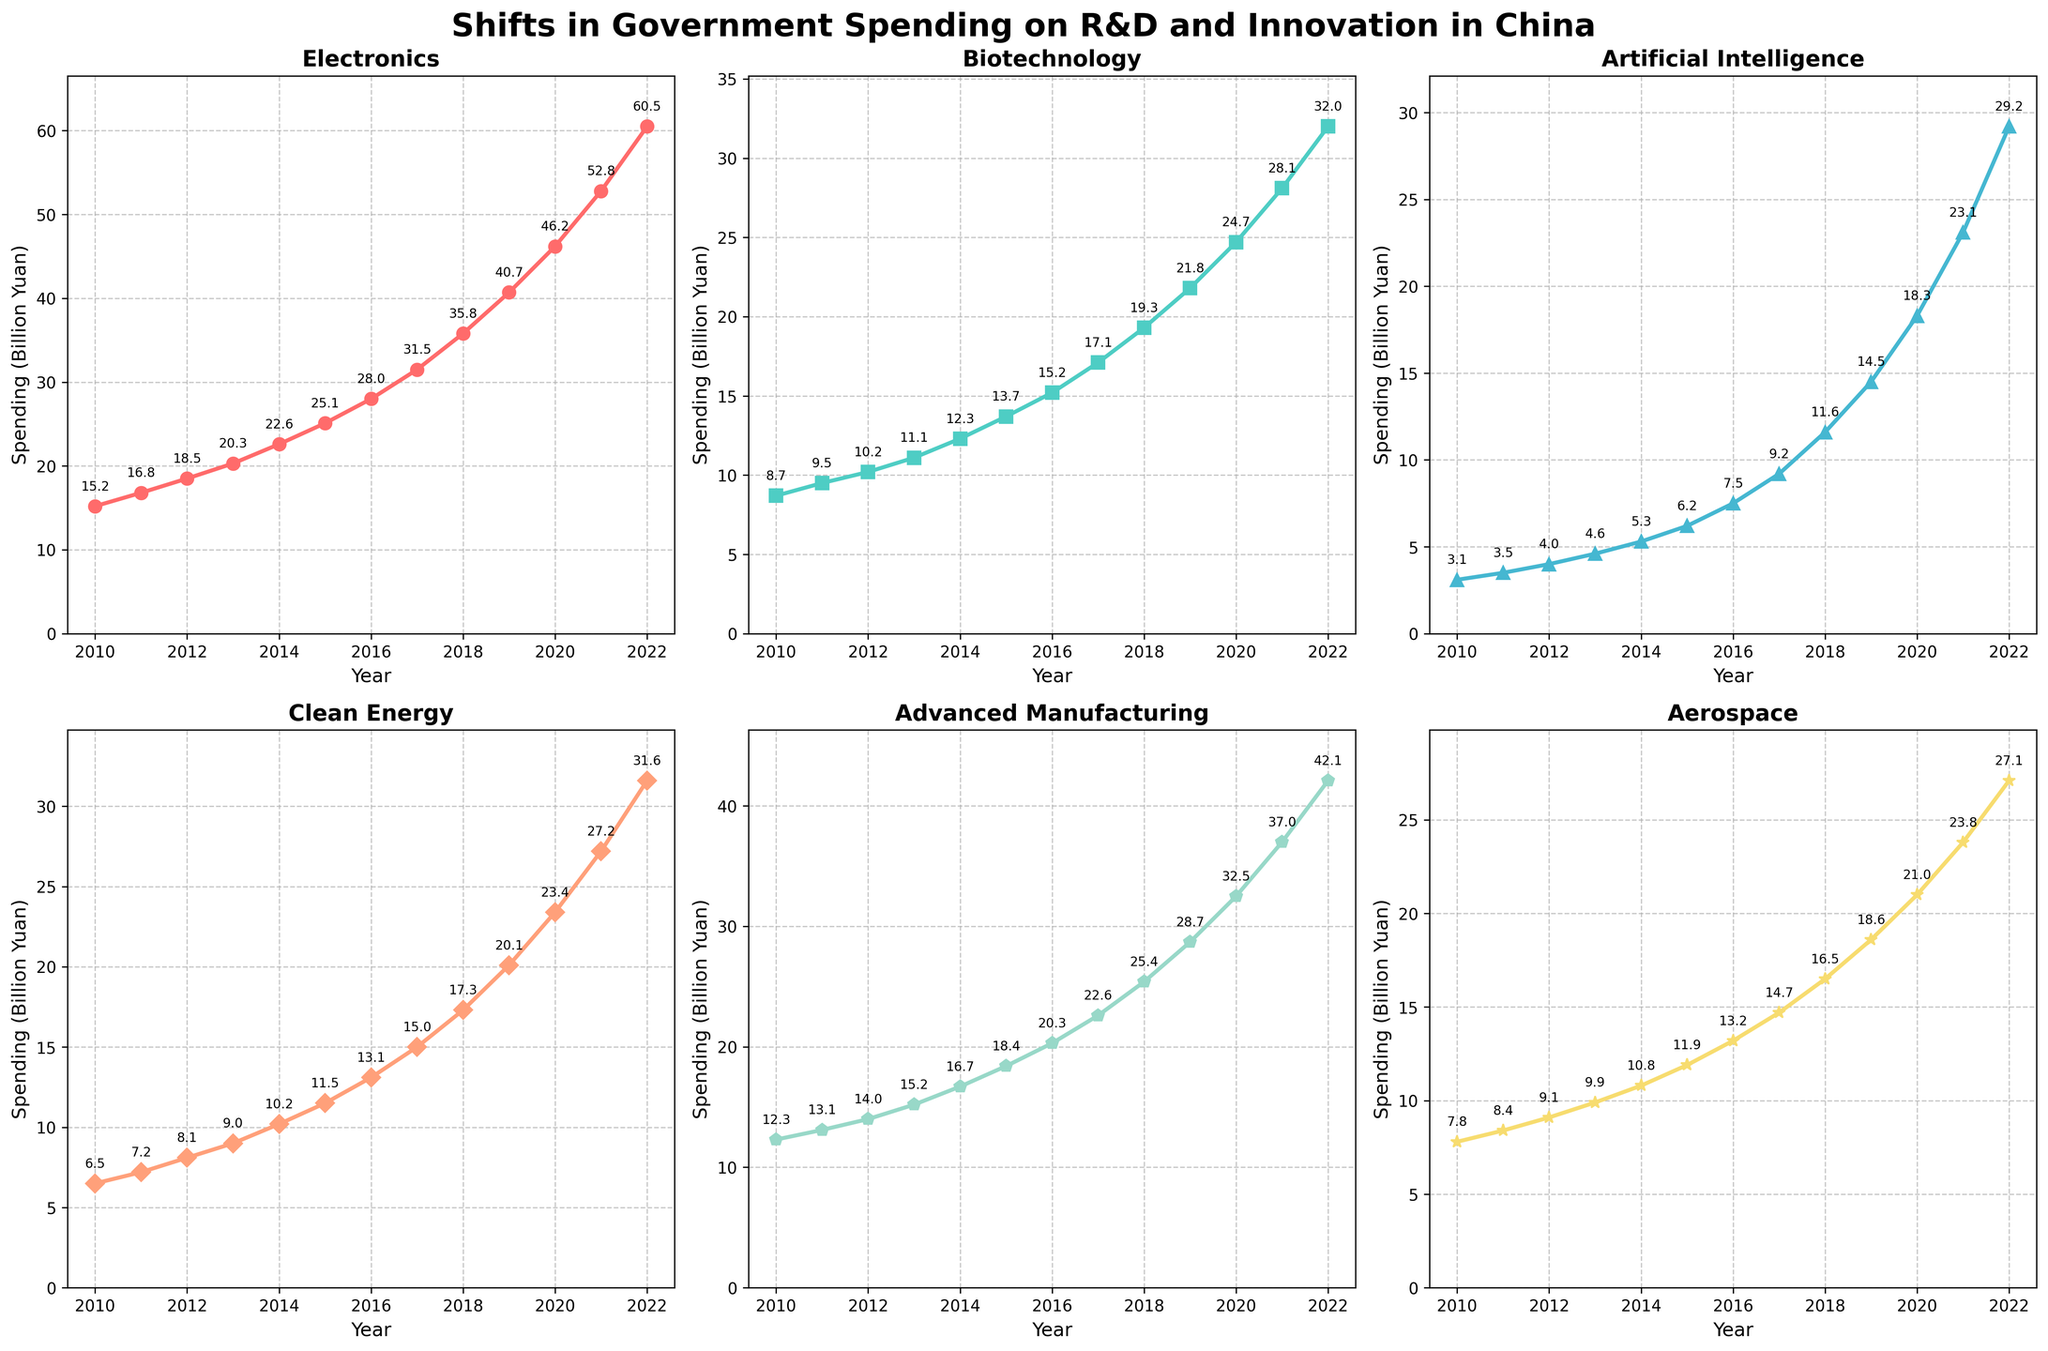Which industry had the highest increase in government spending from 2010 to 2022? To find the highest increase in spending, we can calculate the difference between the spending in 2022 and 2010 for each industry. Electronics: 60.5 - 15.2 = 45.3, Biotechnology: 32.0 - 8.7 = 23.3, Artificial Intelligence: 29.2 - 3.1 = 26.1, Clean Energy: 31.6 - 6.5 = 25.1, Advanced Manufacturing: 42.1 - 12.3 = 29.8, Aerospace: 27.1 - 7.8 = 19.3. The industry with the highest increase is Electronics.
Answer: Electronics How did government spending on Biotechnology change between 2015 and 2022? To determine the change, subtract the spending in 2015 from the spending in 2022 for Biotechnology. The spending in 2015 was 13.7 billion yuan, and in 2022 it was 32.0 billion yuan. 32.0 - 13.7 = 18.3 billion yuan
Answer: 18.3 billion yuan Which industry's spending surpassed 20 billion yuan first, and in which year? By observing the data trends in the figure, we look for the point where each industry's spending crosses 20 billion yuan for the first time. Electronics crossed 20 billion yuan by 2013. Other industries surpassed 20 billion yuan later.
Answer: Electronics, 2013 What is the average government spending on Artificial Intelligence from 2010 to 2022? Adding the spending values from 2010 to 2022 for Artificial Intelligence: 3.1, 3.5, 4.0, 4.6, 5.3, 6.2, 7.5, 9.2, 11.6, 14.5, 18.3, 23.1, 29.2; sum = 140.1. Number of years = 13. Average = 140.1 / 13 = 10.78 billion yuan
Answer: 10.78 billion yuan Compare the trends in spending on Clean Energy and Aerospace from 2010 to 2022. Which industry experienced slower growth? By examining the slope of the lines representing Clean Energy and Aerospace, we can visually identify that Aerospace had slower growth. Clean Energy shows a steeper and more consistent upward trend, while Aerospace's growth is more moderate.
Answer: Aerospace In which year did Advanced Manufacturing spending first exceed 30 billion yuan? Refer to the line representing Advanced Manufacturing. In 2020, spending on Advanced Manufacturing was 32.5 billion yuan, the first year it exceeded 30 billion yuan.
Answer: 2020 How does the spending in 2021 for Clean Energy compare to that in 2022? Observing the spending in the figure, Clean Energy shows 27.2 billion yuan in 2021 and 31.6 billion yuan in 2022. Subtracting the two, the increase is 31.6 - 27.2 = 4.4 billion yuan, indicating an increase.
Answer: Increased by 4.4 billion yuan Between 2018 and 2020, which industry showed the highest rate of increase in spending? Calculate the rate of increase for each industry between 2018 and 2020 by finding the percentage change. Electronics: (46.2-35.8)/35.8 = 0.2905 (29.05%), Biotechnology: (24.7-19.3)/19.3 = 0.2793 (27.93%), AI: (18.3-11.6)/11.6 = 0.5776 (57.76%), Clean Energy: (23.4-17.3)/17.3 = 0.3520 (35.20%), Advanced Manufacturing: (32.5-25.4)/25.4 = 0.2795 (27.95%), Aerospace: (21.0-16.5)/16.5 = 0.2727 (27.27%). The highest rate of increase is for AI at 57.76%.
Answer: Artificial Intelligence 